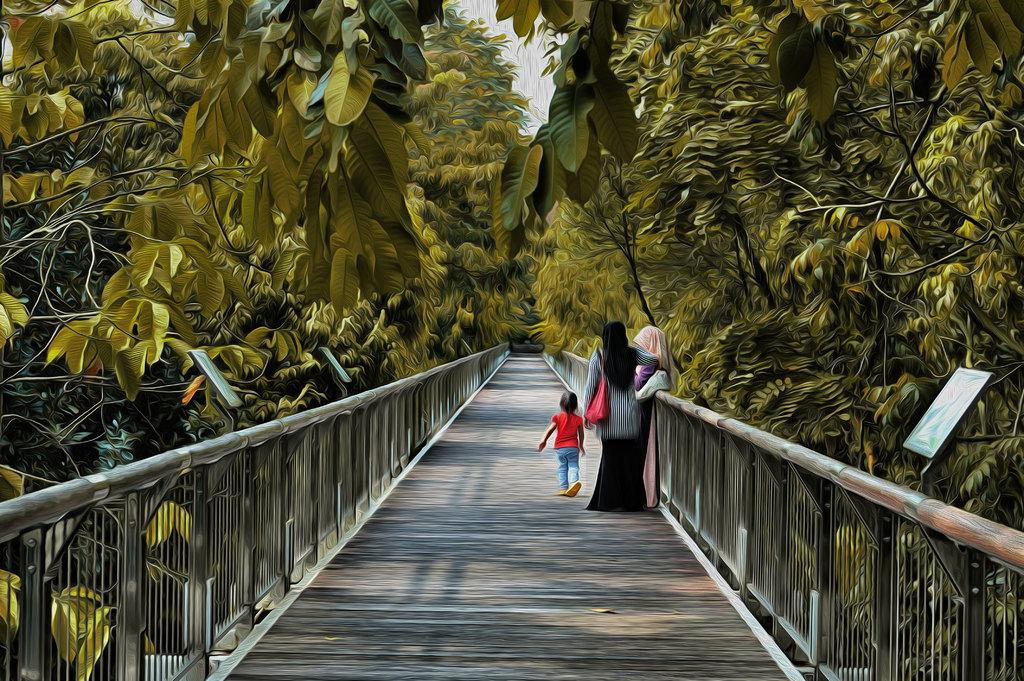How many women are in the image? There are two women in the image. What are the women doing in the image? The women are standing on a bridge. Can you describe the girl in the image? The girl is wearing a red dress and walking on the bridge. What can be seen on either side of the bridge? There are street lights and trees on either side of the bridge. What type of building can be seen in the image? There is no building present in the image; it features two women and a girl on a bridge with street lights and trees on either side. 